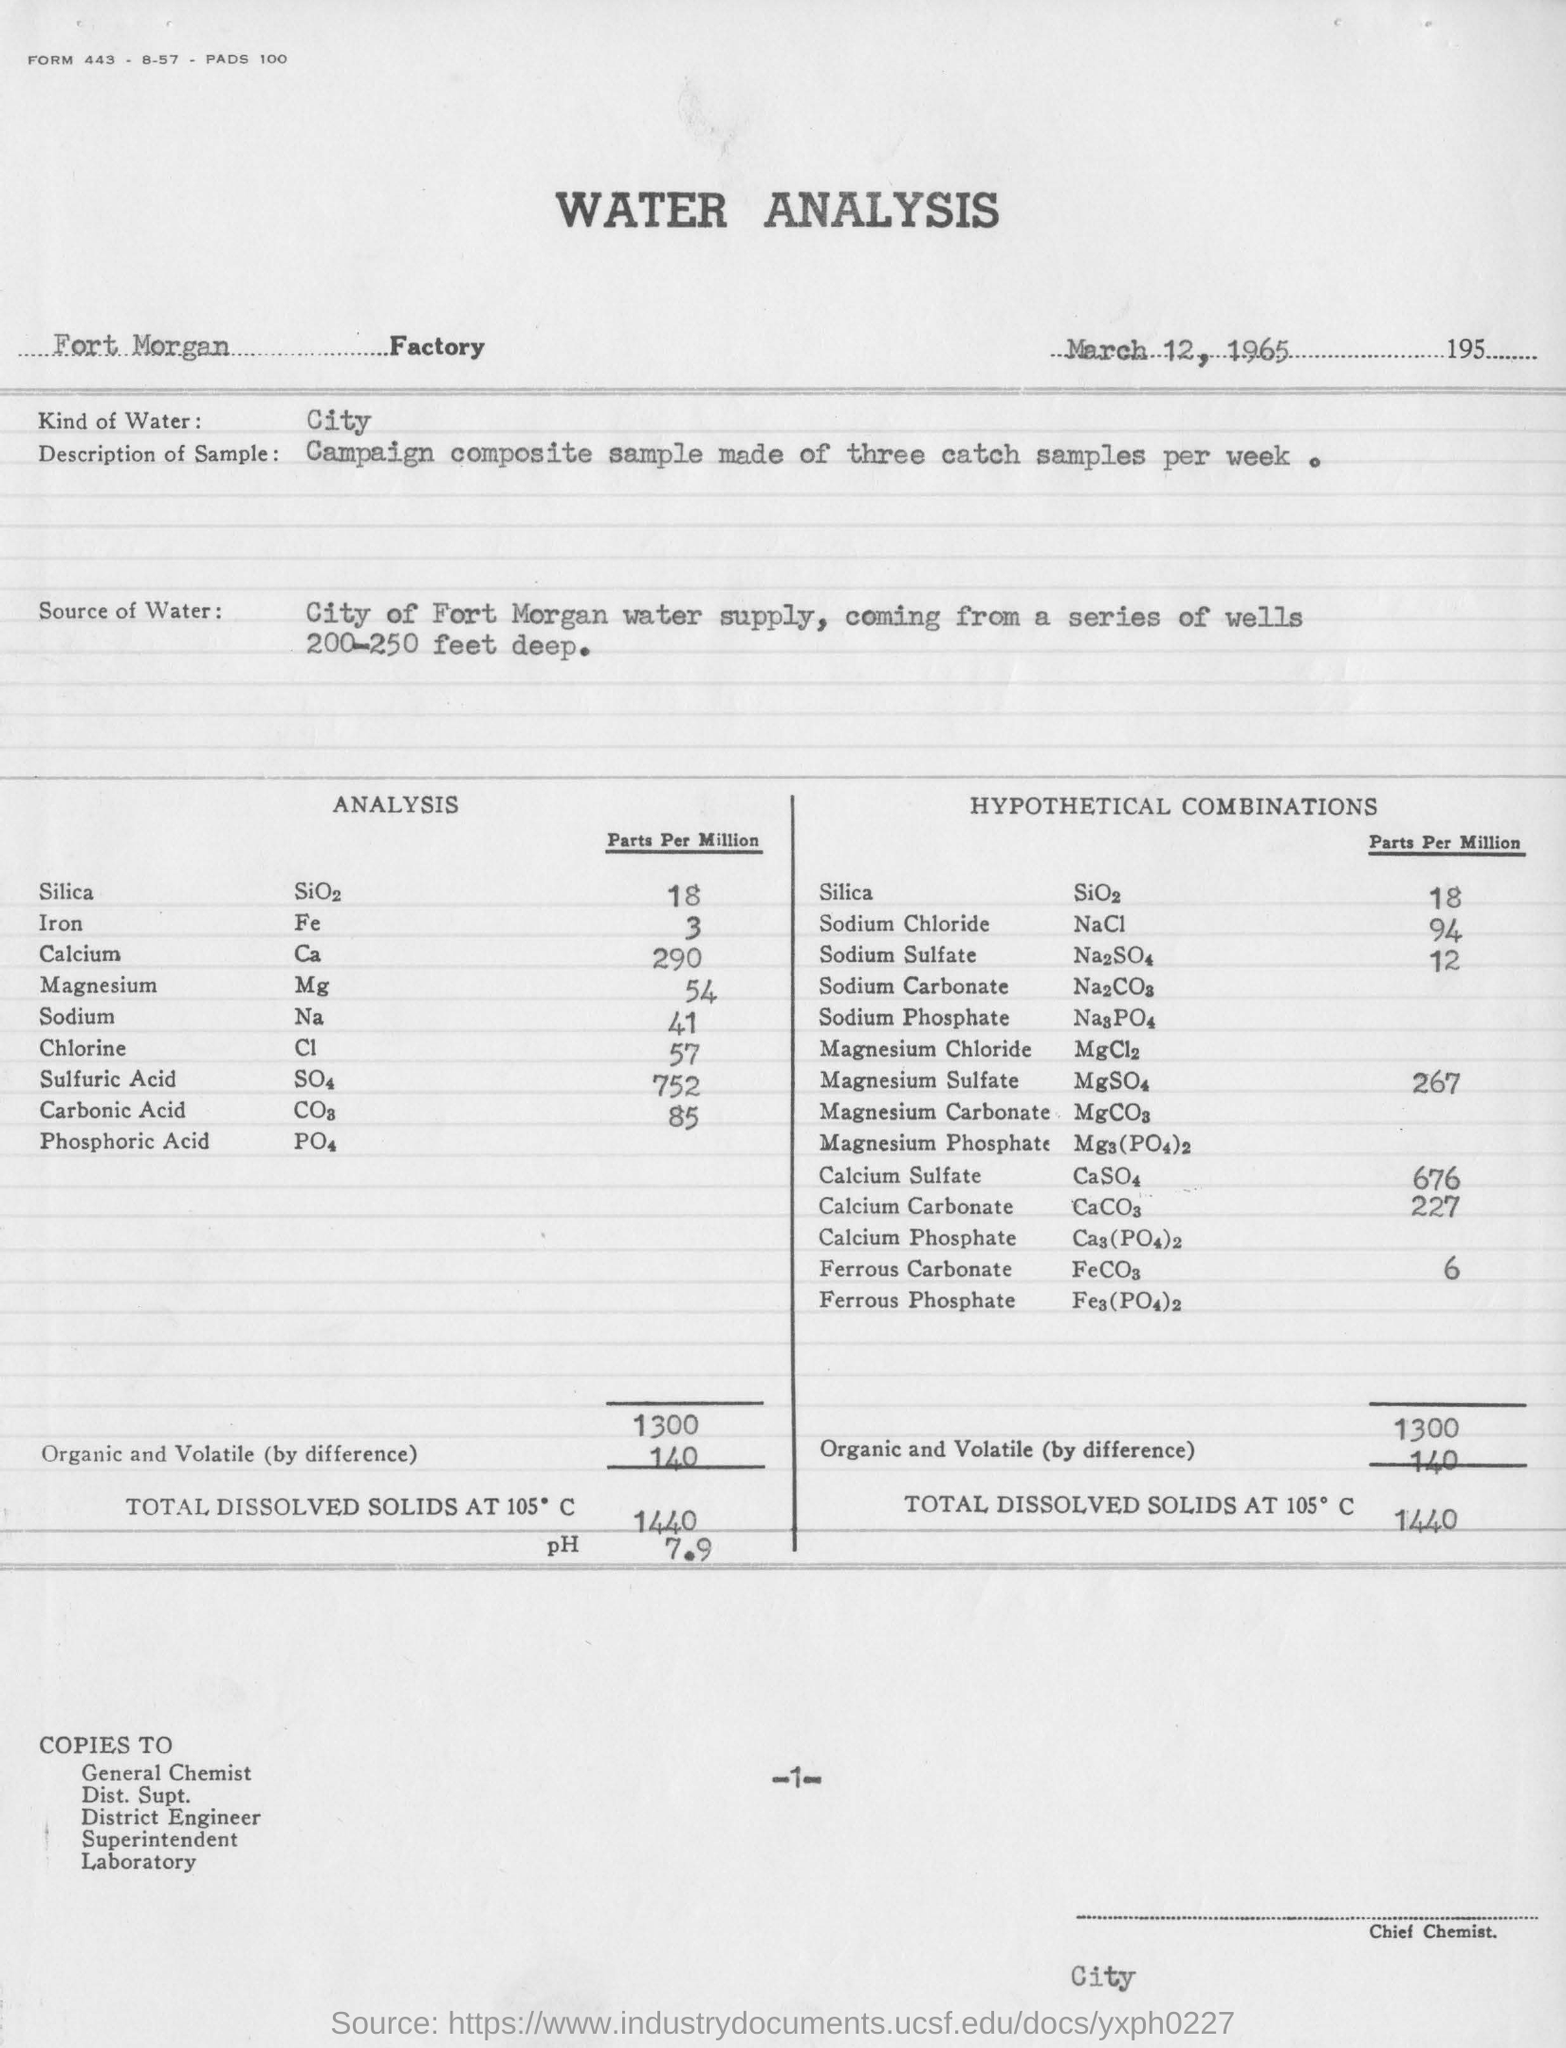Highlight a few significant elements in this photo. The report was created on March 12, 1965. The City of Fort Morgan's water supply is sourced from a series of wells that are 200-250 feet deep, providing a reliable source of water for the community. It is a type of water that is specific to the city. 